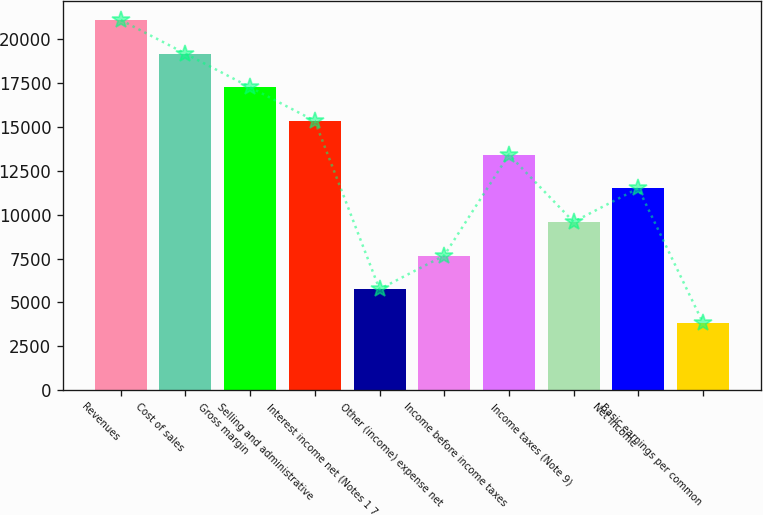Convert chart. <chart><loc_0><loc_0><loc_500><loc_500><bar_chart><fcel>Revenues<fcel>Cost of sales<fcel>Gross margin<fcel>Selling and administrative<fcel>Interest income net (Notes 1 7<fcel>Other (income) expense net<fcel>Income before income taxes<fcel>Income taxes (Note 9)<fcel>Net income<fcel>Basic earnings per common<nl><fcel>21093.6<fcel>19176.1<fcel>17258.6<fcel>15341.1<fcel>5753.51<fcel>7671.02<fcel>13423.5<fcel>9588.53<fcel>11506<fcel>3836<nl></chart> 